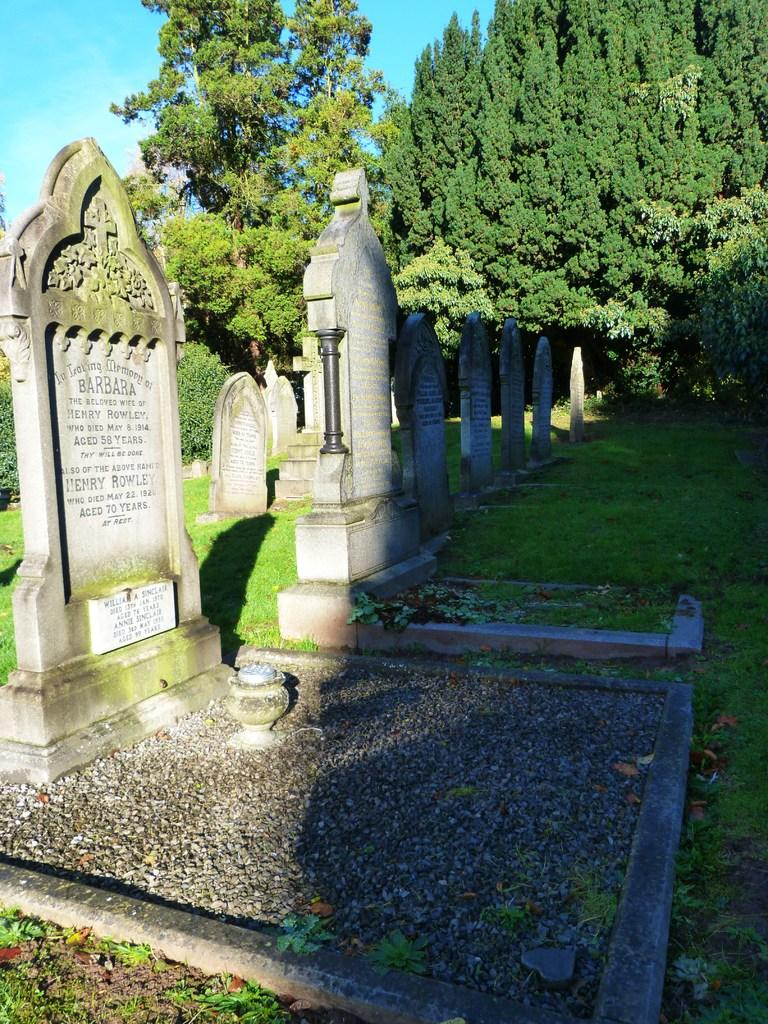What type of structures are present in the image? There are memorials in the picture. What type of ground is visible at the bottom of the image? There is grass at the bottom of the image. What type of vegetation can be seen in the background of the image? There are trees in the background of the image. What part of the sky is visible in the image? The sky is visible at the left top of the image. What color is the paint on the shirt of the person standing next to the memorial? There is no person or shirt present in the image, so it is not possible to determine the color of the paint on the shirt. 